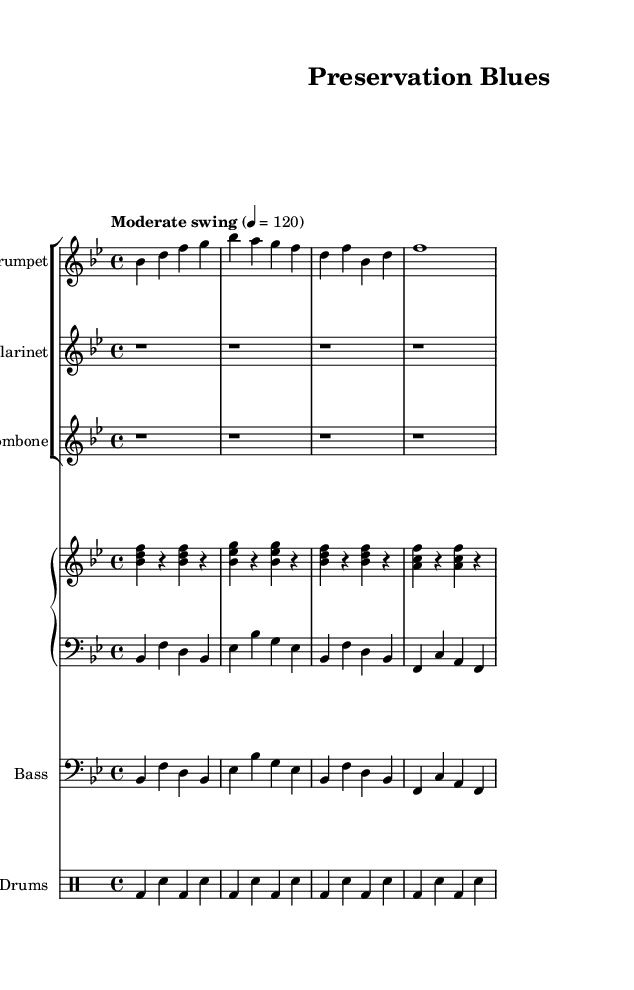What is the key signature of this music? The key signature indicated at the beginning of the sheet music shows two flats (B flat and E flat), which means it is in B flat major.
Answer: B flat major What is the time signature of this music? The time signature is shown at the beginning of the piece as 4/4, meaning there are four beats in each measure and a quarter note gets one beat.
Answer: 4/4 What is the tempo marking for this piece? The tempo marking indicates "Moderate swing" with a metronome mark of 120, suggesting a relaxed and swinging feel at that speed.
Answer: Moderate swing 4 = 120 How many measures are there in the trumpet part? To find out, I count the groups of notes in the trumpet part. There are four measures of music written for the trumpet.
Answer: 4 Which instrument has a rest for the entire duration of the piece? The clarinet part shows four measures of rests, indicating that the clarinet does not play during this section.
Answer: Clarinet What is the rhythmic pattern used for the drums? The drum part shows a consistent alternating pattern of bass drum and snare drum in a simple four-beat sequence. This repetition is characteristic of the style.
Answer: Alternating bass drum and snare Identify the type of jazz piece this music represents. The structure and instrumentation, including the presence of brass and rhythm sections, along with the title "Preservation Blues," suggest that it embodies 1920s New Orleans jazz, often associated with blues influences.
Answer: New Orleans jazz 